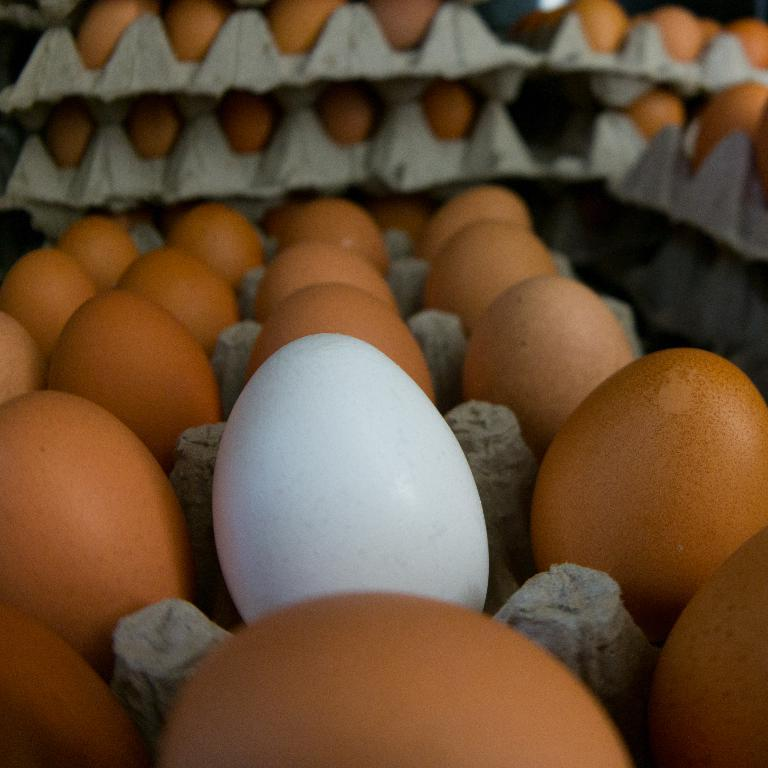What is present in the image? There are eggs in the image. How are the eggs arranged in the image? The eggs are in trays. Can you describe the color of one of the eggs in the image? There is a white-colored egg in the tray. How does the grandfather run in the image? There is no grandfather or running depicted in the image; it only features eggs in trays. 